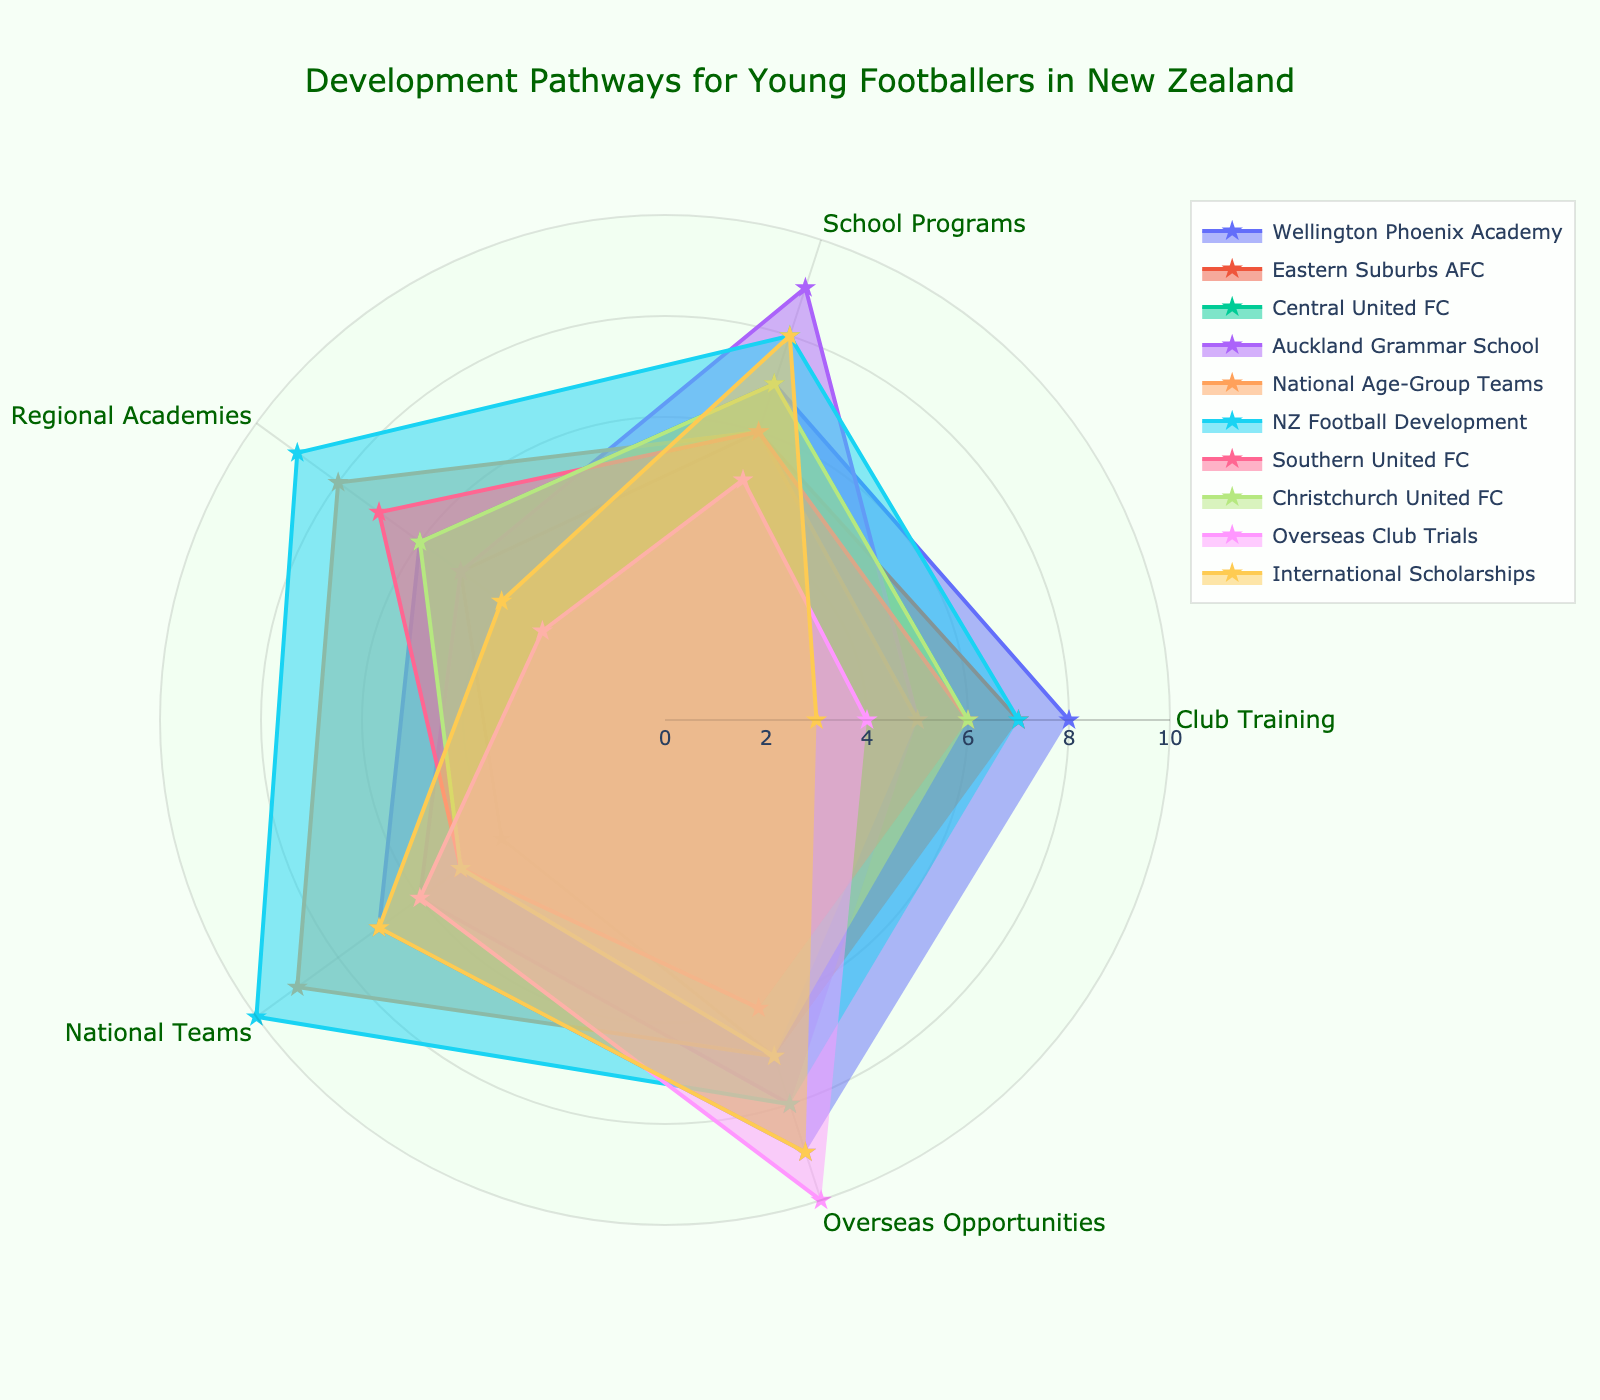what is the title of the radar chart? The title is displayed at the top center of the radar chart in natural language.
Answer: Development Pathways for Young Footballers in New Zealand how many categories are on the radar chart? By looking at the radar chart, count the number of axes or dimensions that extend from the center.
Answer: 5 which pathway has the highest score for Overseas Opportunities? Find the category (pathway) with the highest value along the "Overseas Opportunities" axis.
Answer: Overseas Club Trials what is the average score of NZ Football Development across all categories? Sum the values given for NZ Football Development across all categories and divide by the number of categories (5).
Answer: 8.4 which two pathways have equal scores for Club Training, and what are they? Identify two categories with the same value on the "Club Training" axis and name those categories.
Answer: National Age-Group Teams and Central United FC how does the score of Auckland Grammar School's School Programs compare to Wellington Phoenix Academy's School Programs? Find and compare the scores of Auckland Grammar School and Wellington Phoenix Academy on the "School Programs" axis.
Answer: higher which pathway has the most balanced score distribution across all categories, and what is the highest and lowest score for that pathway? Identify the category with scores closest together across all axes, and find its highest and lowest scores.
Answer: NZ Football Development, highest: 10, lowest: 7 what is the difference in the National Teams score between Southern United FC and National Age-Group Teams? Subtract Southern United FC's value for "National Teams" from National Age-Group Teams' value for the same category.
Answer: 4 which pathway has the lowest score for Regional Academies and what is the score? Identify the category with the lowest value on the "Regional Academies" axis.
Answer: Overseas Club Trials, score: 3 which pathway has the highest overall score when summing the values across all categories, and what is the total score? Sum the values for each category and identify the one with the highest total. Compute its total score.
Answer: NZ Football Development, total score: 42 